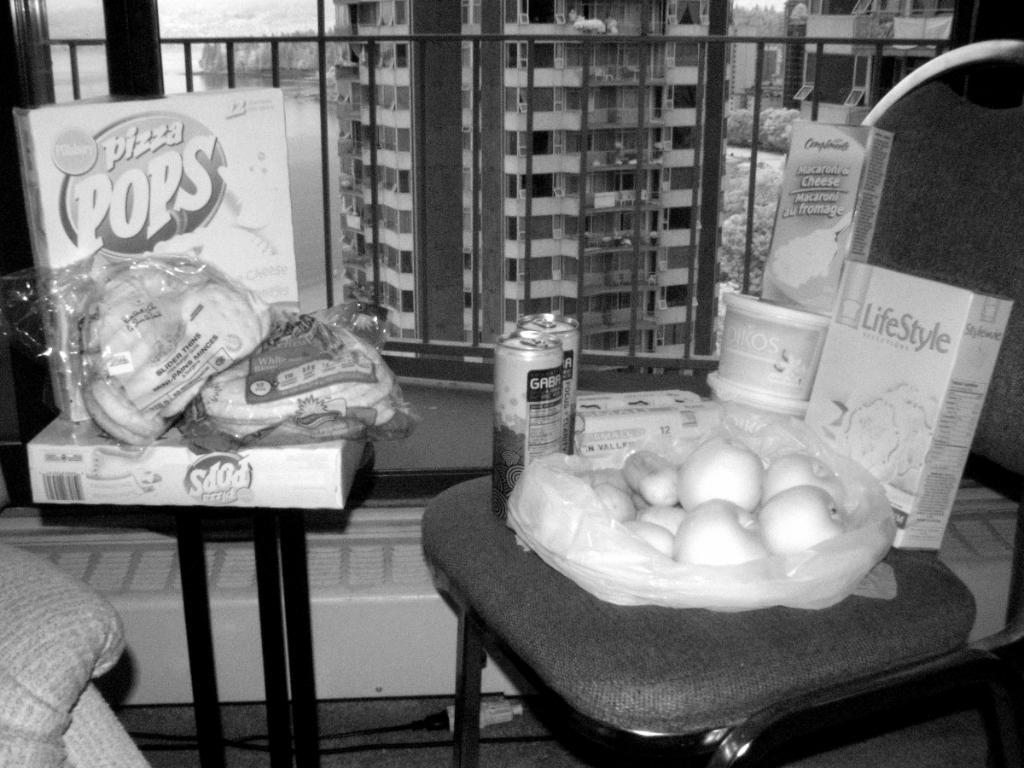How would you summarize this image in a sentence or two? This is a black and white image and here we can see boxes, tins, fruits, covers and some other objects on the chairs. In the background, we can see buildings. At the bottom, there is a floor. 